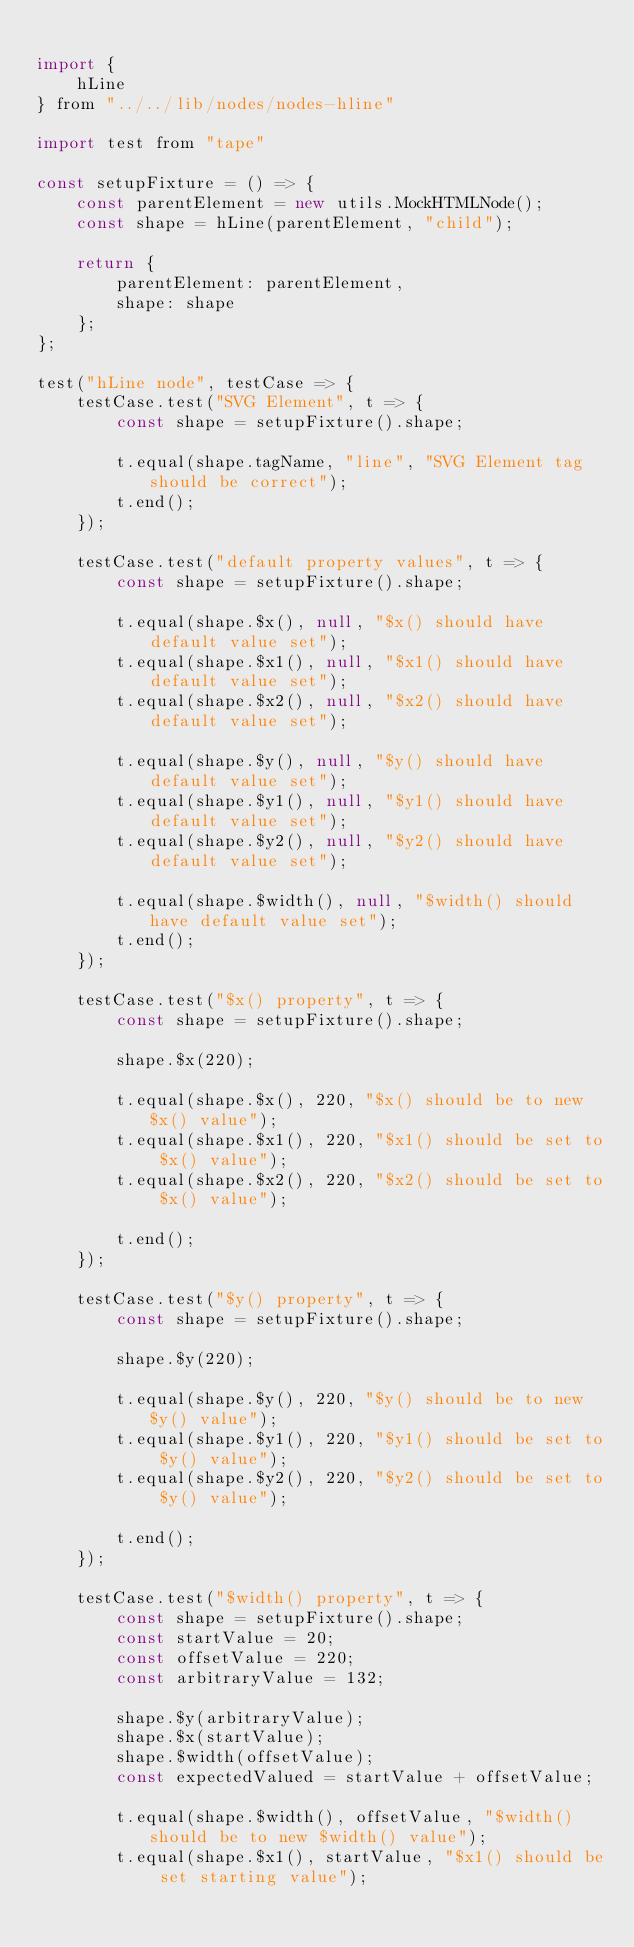<code> <loc_0><loc_0><loc_500><loc_500><_JavaScript_>
import {
    hLine
} from "../../lib/nodes/nodes-hline"

import test from "tape"

const setupFixture = () => {
    const parentElement = new utils.MockHTMLNode();
    const shape = hLine(parentElement, "child");

    return {
        parentElement: parentElement,
        shape: shape
    };
};

test("hLine node", testCase => {
    testCase.test("SVG Element", t => {
        const shape = setupFixture().shape;

        t.equal(shape.tagName, "line", "SVG Element tag should be correct");
        t.end();
    });

    testCase.test("default property values", t => {
        const shape = setupFixture().shape;

        t.equal(shape.$x(), null, "$x() should have default value set");
        t.equal(shape.$x1(), null, "$x1() should have default value set");
        t.equal(shape.$x2(), null, "$x2() should have default value set");

        t.equal(shape.$y(), null, "$y() should have default value set");
        t.equal(shape.$y1(), null, "$y1() should have default value set");
        t.equal(shape.$y2(), null, "$y2() should have default value set");

        t.equal(shape.$width(), null, "$width() should have default value set");
        t.end();
    });

    testCase.test("$x() property", t => {
        const shape = setupFixture().shape;

        shape.$x(220);

        t.equal(shape.$x(), 220, "$x() should be to new $x() value");
        t.equal(shape.$x1(), 220, "$x1() should be set to $x() value");
        t.equal(shape.$x2(), 220, "$x2() should be set to $x() value");

        t.end();
    });

    testCase.test("$y() property", t => {
        const shape = setupFixture().shape;

        shape.$y(220);

        t.equal(shape.$y(), 220, "$y() should be to new $y() value");
        t.equal(shape.$y1(), 220, "$y1() should be set to $y() value");
        t.equal(shape.$y2(), 220, "$y2() should be set to $y() value");

        t.end();
    });

    testCase.test("$width() property", t => {
        const shape = setupFixture().shape;
        const startValue = 20;
        const offsetValue = 220;
        const arbitraryValue = 132;

        shape.$y(arbitraryValue);
        shape.$x(startValue);
        shape.$width(offsetValue);
        const expectedValued = startValue + offsetValue;

        t.equal(shape.$width(), offsetValue, "$width() should be to new $width() value");
        t.equal(shape.$x1(), startValue, "$x1() should be set starting value");</code> 